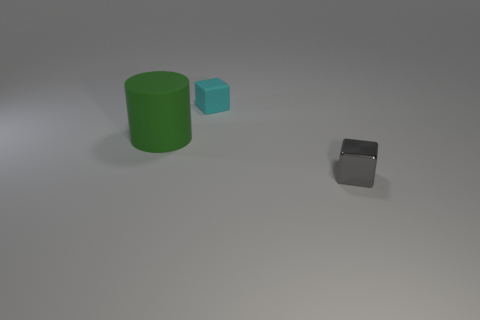Add 1 brown shiny balls. How many objects exist? 4 Subtract all blocks. How many objects are left? 1 Subtract all green cylinders. How many green cubes are left? 0 Subtract 0 purple cylinders. How many objects are left? 3 Subtract 1 blocks. How many blocks are left? 1 Subtract all gray blocks. Subtract all red cylinders. How many blocks are left? 1 Subtract all tiny yellow cylinders. Subtract all cubes. How many objects are left? 1 Add 3 small cubes. How many small cubes are left? 5 Add 2 small brown shiny cubes. How many small brown shiny cubes exist? 2 